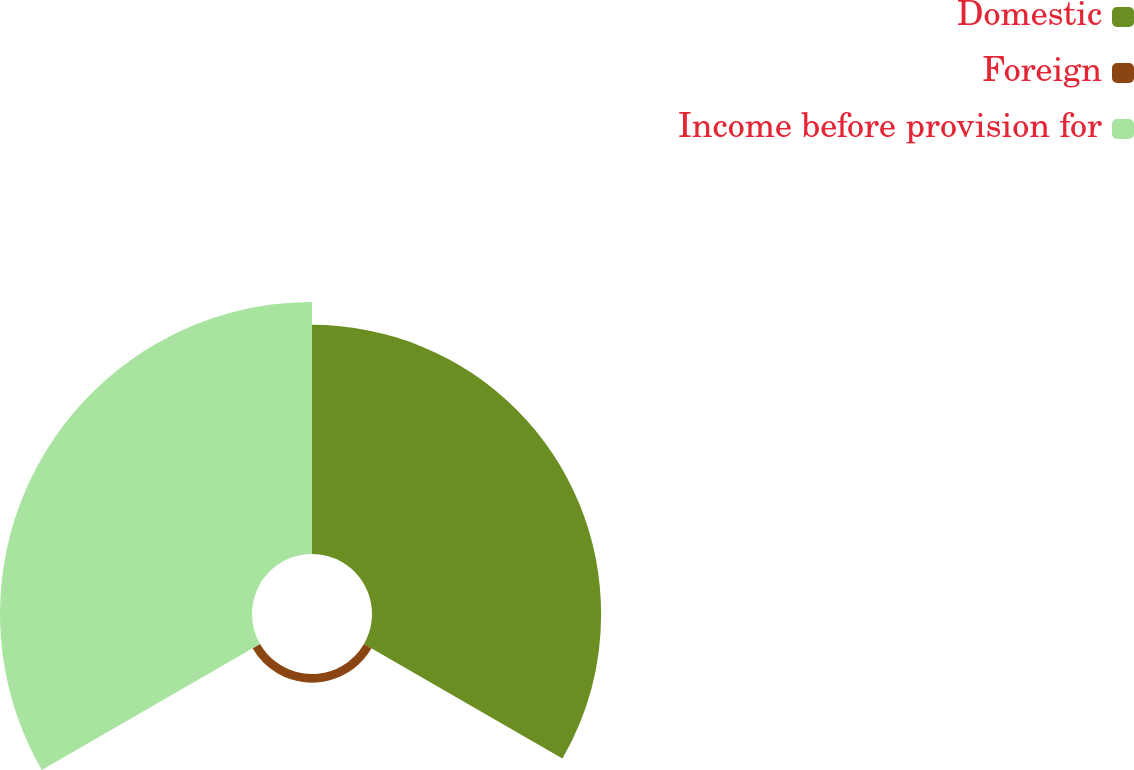Convert chart. <chart><loc_0><loc_0><loc_500><loc_500><pie_chart><fcel>Domestic<fcel>Foreign<fcel>Income before provision for<nl><fcel>46.78%<fcel>1.77%<fcel>51.45%<nl></chart> 